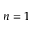Convert formula to latex. <formula><loc_0><loc_0><loc_500><loc_500>n = 1</formula> 